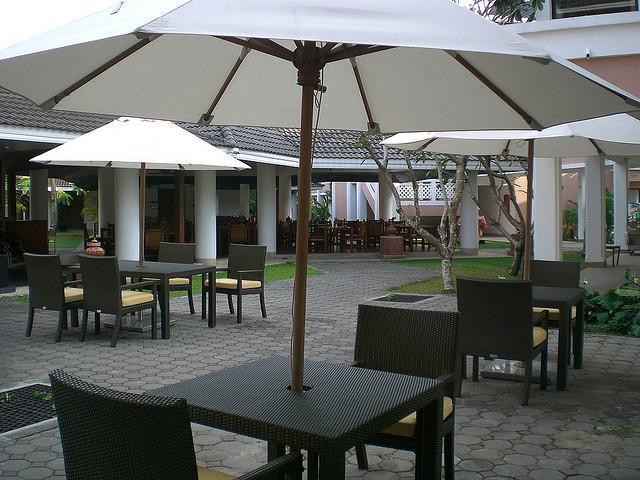How many chairs at the 3 tables?
Give a very brief answer. 8. How many dining tables can be seen?
Give a very brief answer. 3. How many umbrellas can you see?
Give a very brief answer. 3. How many chairs are visible?
Give a very brief answer. 6. How many people are wearing hats?
Give a very brief answer. 0. 